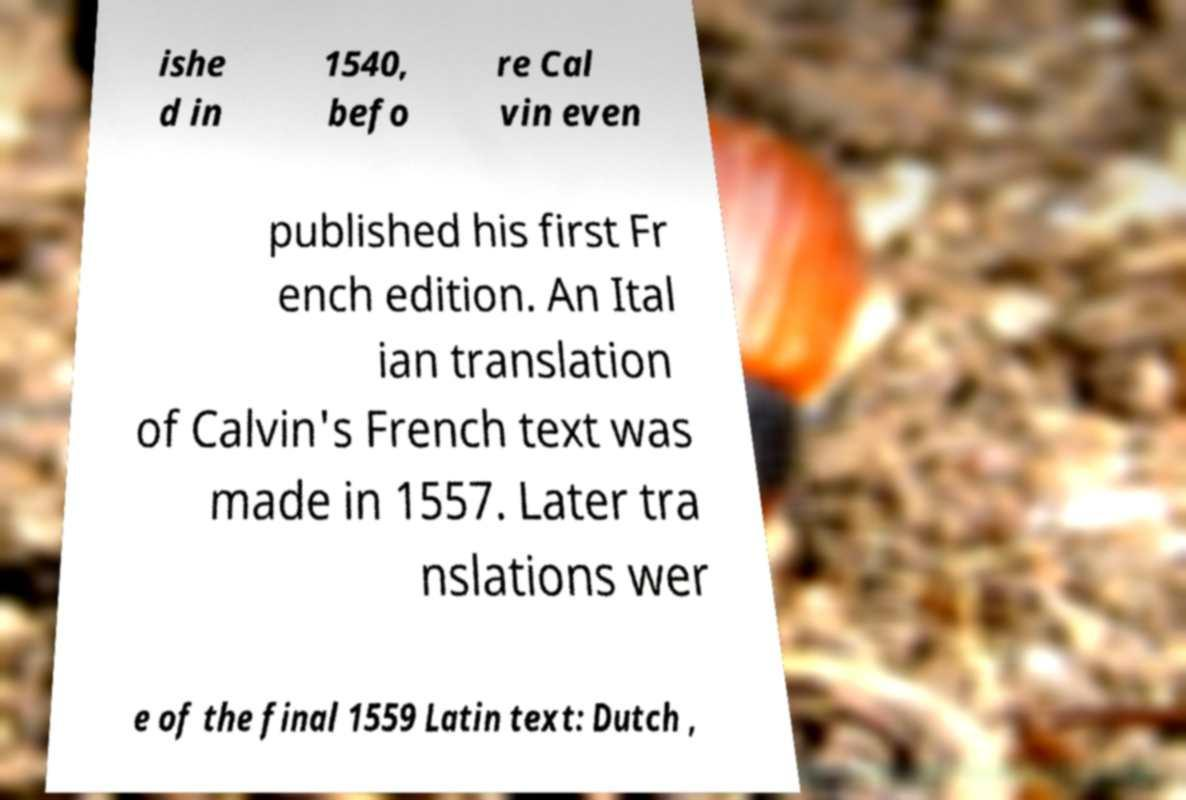Please identify and transcribe the text found in this image. ishe d in 1540, befo re Cal vin even published his first Fr ench edition. An Ital ian translation of Calvin's French text was made in 1557. Later tra nslations wer e of the final 1559 Latin text: Dutch , 